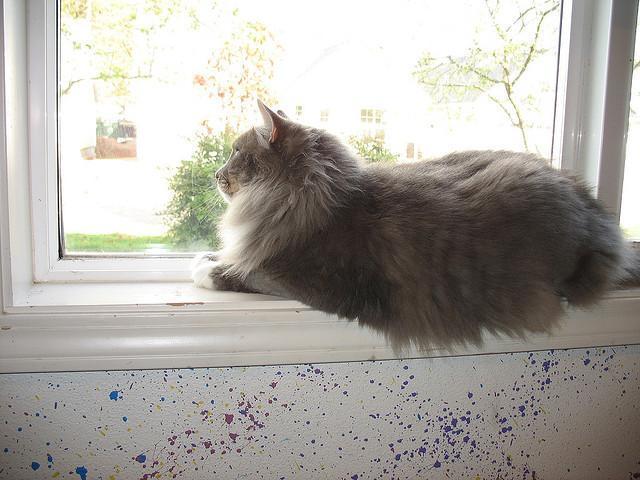How many windows?
Give a very brief answer. 1. How many people are wearing glasses?
Give a very brief answer. 0. 